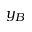Convert formula to latex. <formula><loc_0><loc_0><loc_500><loc_500>y _ { B }</formula> 